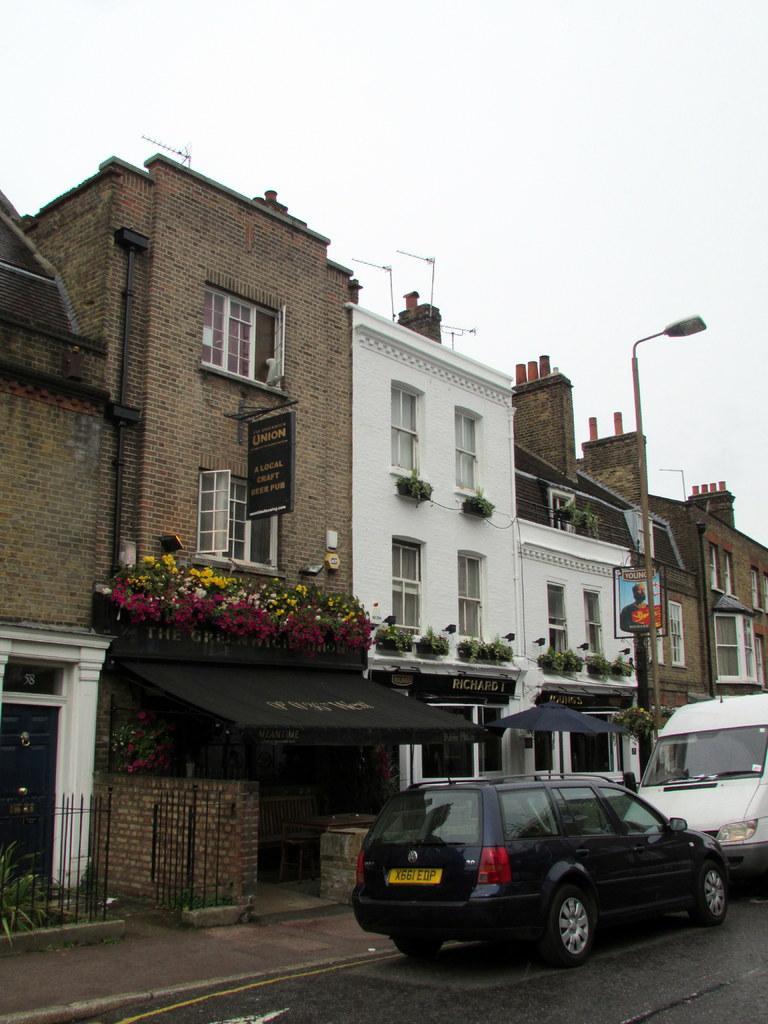Can you describe this image briefly? In this image there is a road on which there are two cars. Behind the cars there are buildings with the windows. On the footpath there is an iron gate. Below the building there is a store on which there are flowers. On the street light there is a light. At the top there is sky. 